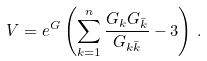<formula> <loc_0><loc_0><loc_500><loc_500>V = e ^ { G } \left ( \sum _ { k = 1 } ^ { n } \frac { G _ { k } G _ { \bar { k } } } { G _ { k \bar { k } } } - 3 \right ) \, .</formula> 